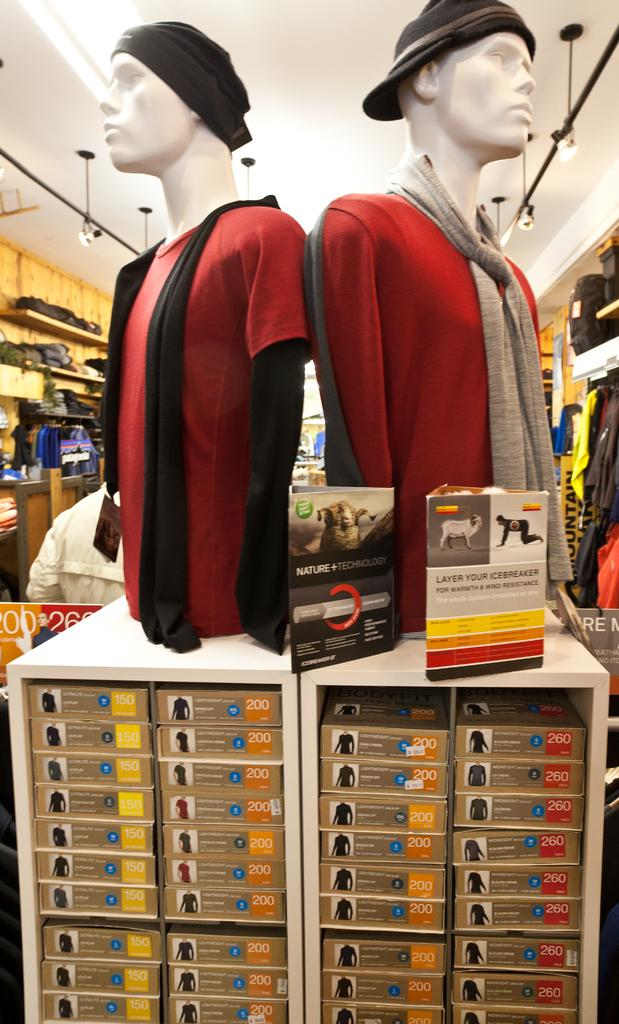How many objects with red clothes are in the image? There are two objects with red clothes in the image. Can you describe the other objects in the background of the image? Unfortunately, the provided facts do not give any information about the objects in the background. What is the title of the book that the two objects with red clothes are reading in the image? There is no book or reading activity depicted in the image. How many arches can be seen in the image? There is no mention of arches in the provided facts, so we cannot determine their presence or number in the image. 